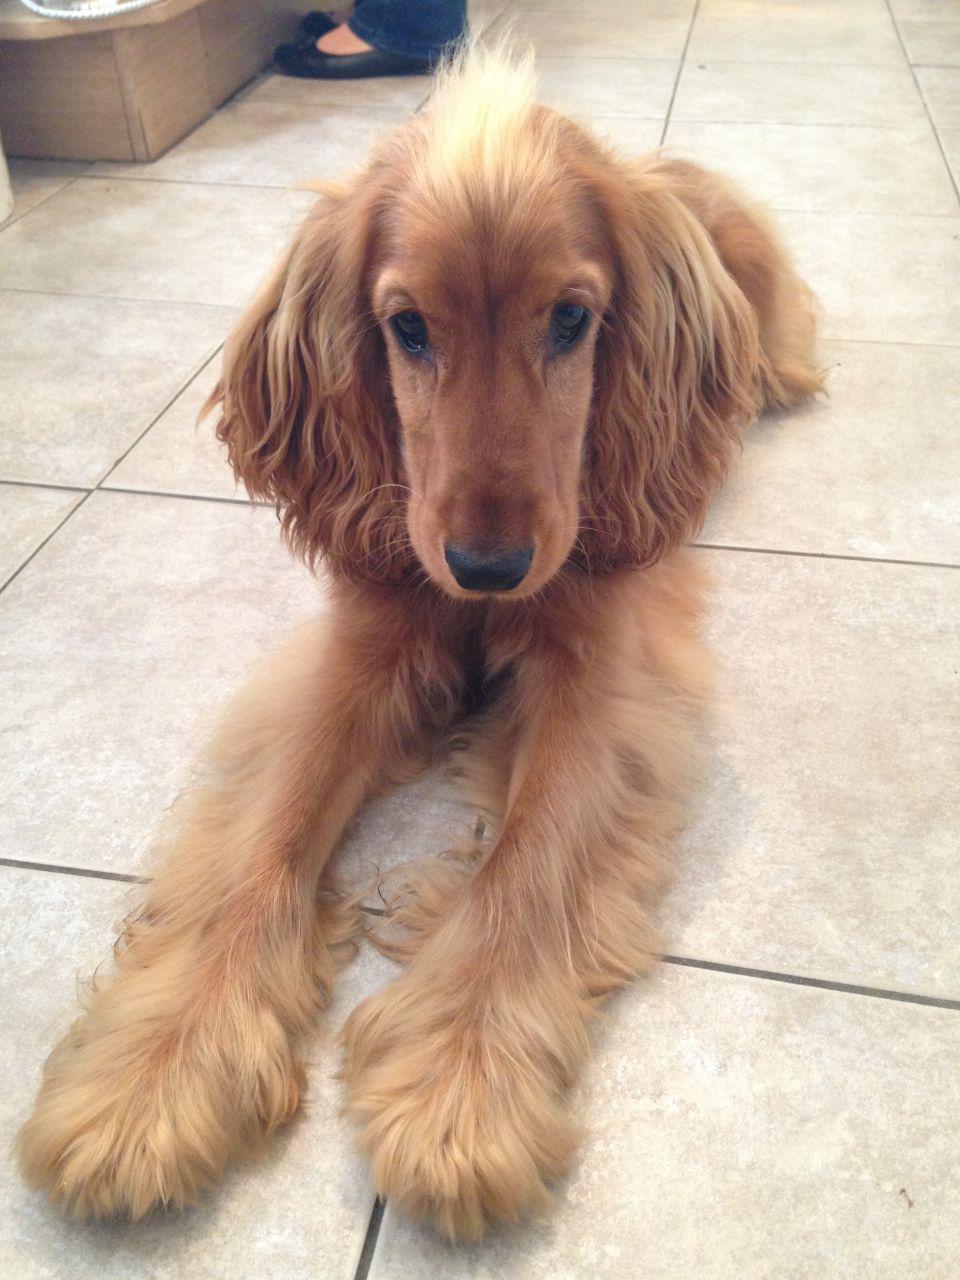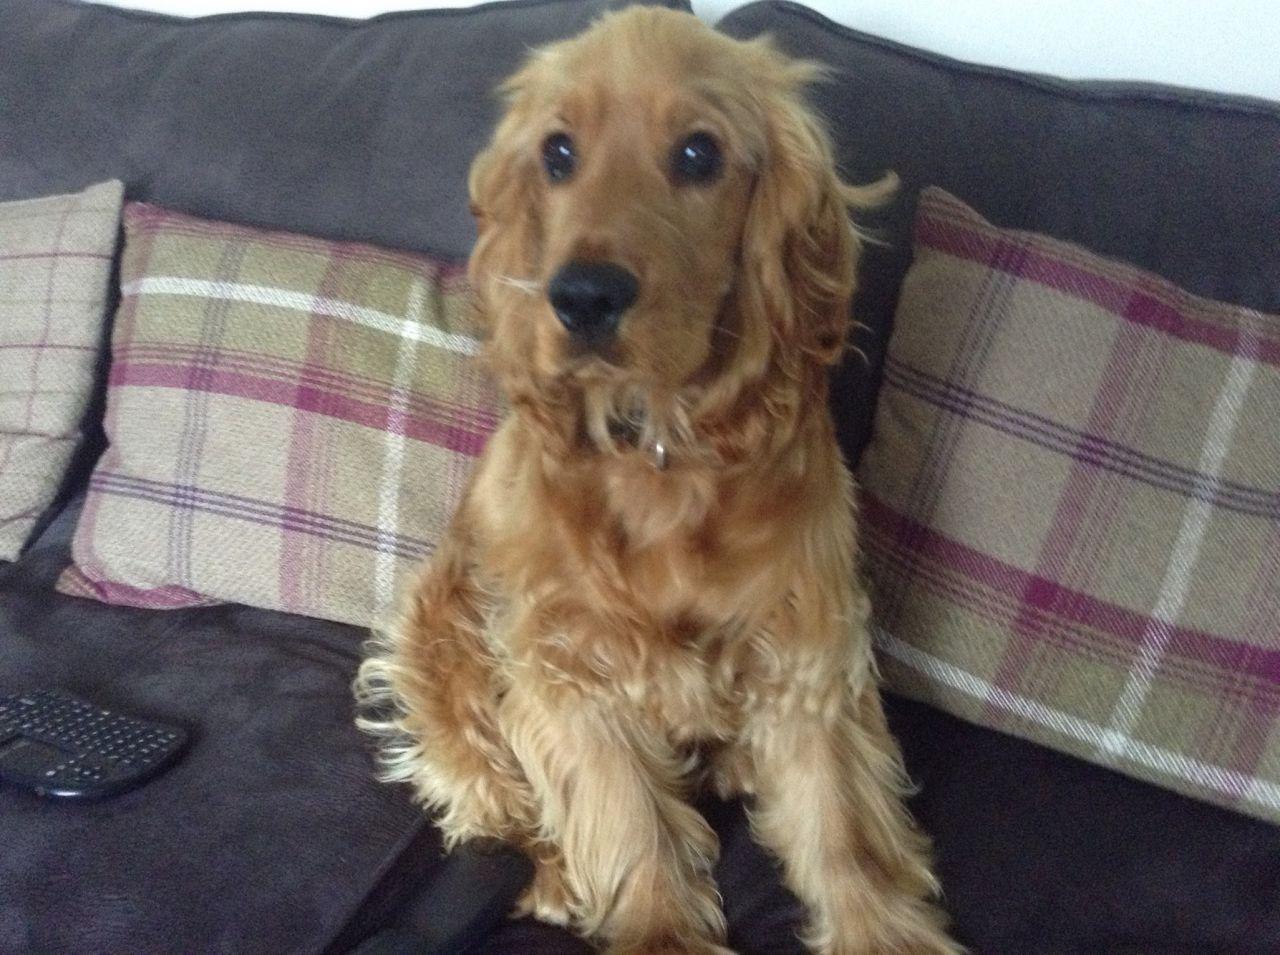The first image is the image on the left, the second image is the image on the right. Considering the images on both sides, is "One dog is laying on a tile floor." valid? Answer yes or no. Yes. The first image is the image on the left, the second image is the image on the right. For the images shown, is this caption "a dog is in front of furniture on a wood floor" true? Answer yes or no. No. 